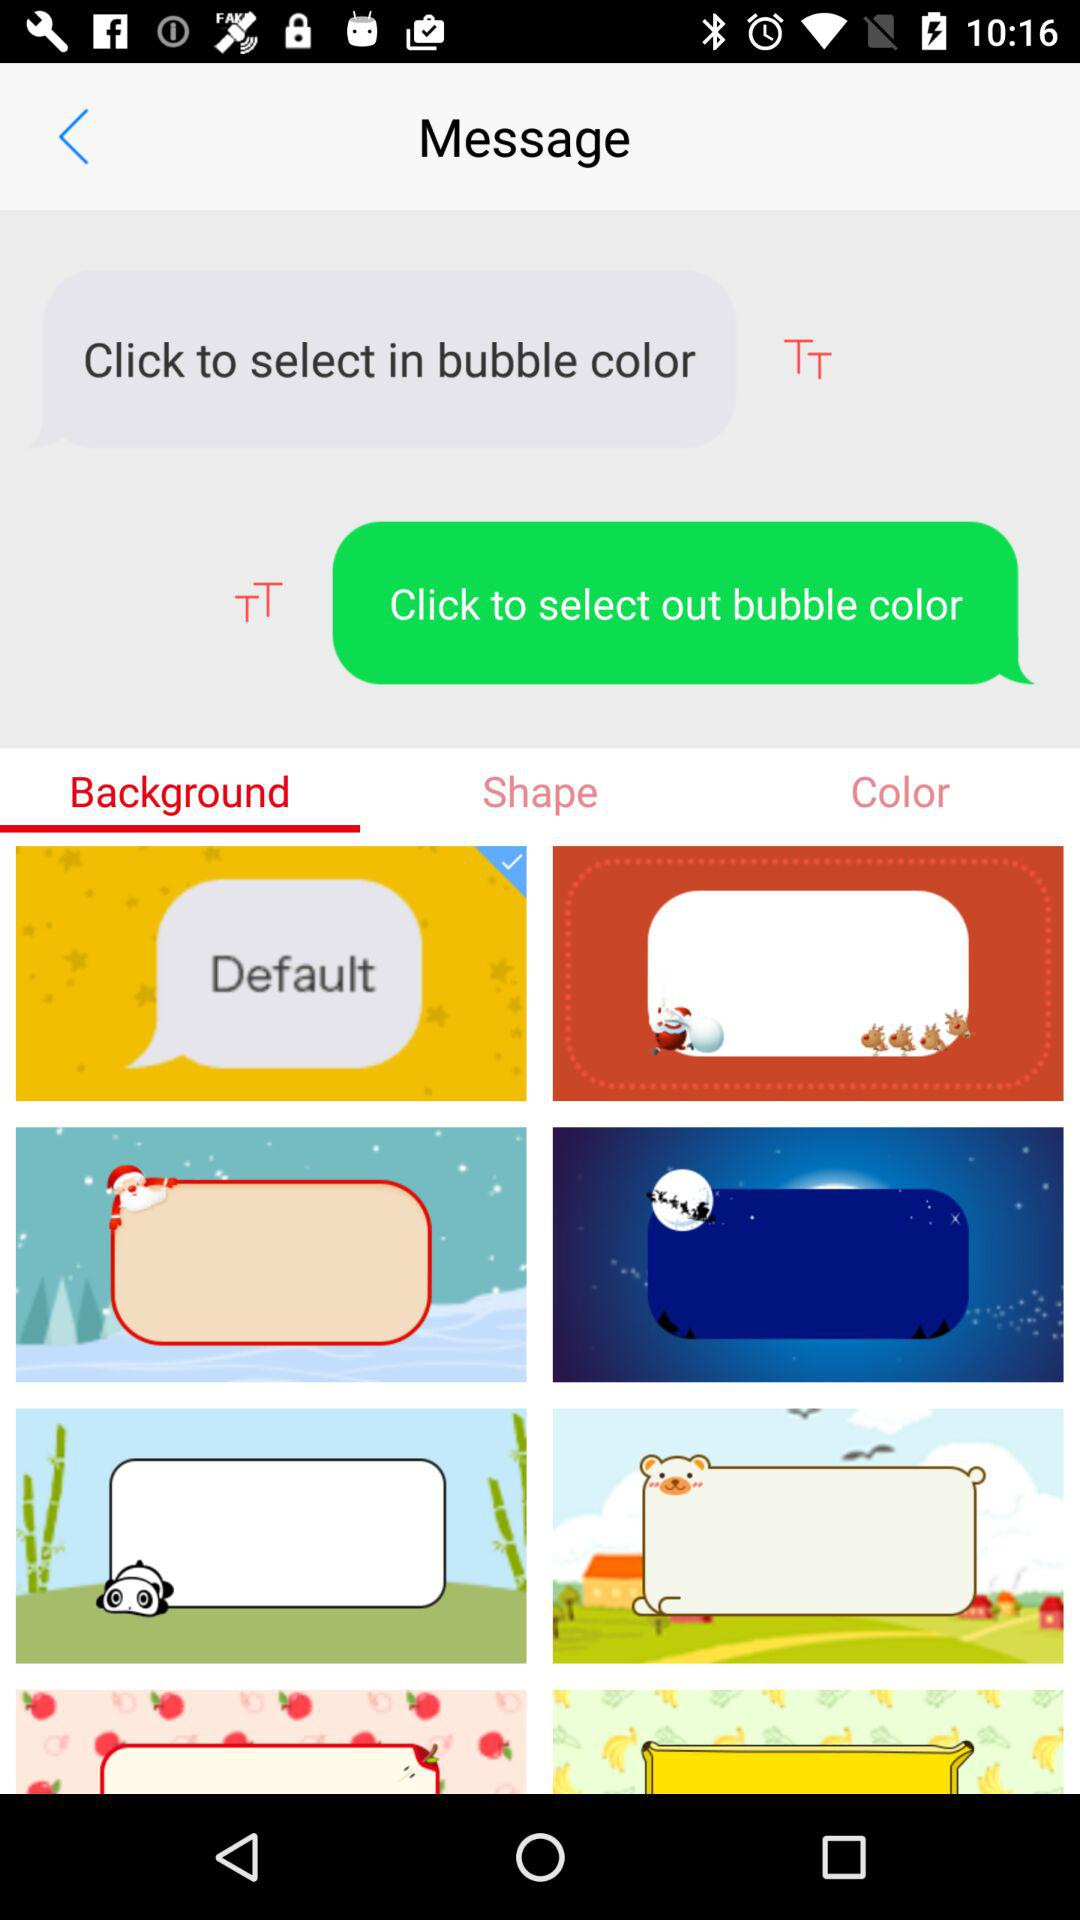Which "Background" option is selected?
When the provided information is insufficient, respond with <no answer>. <no answer> 